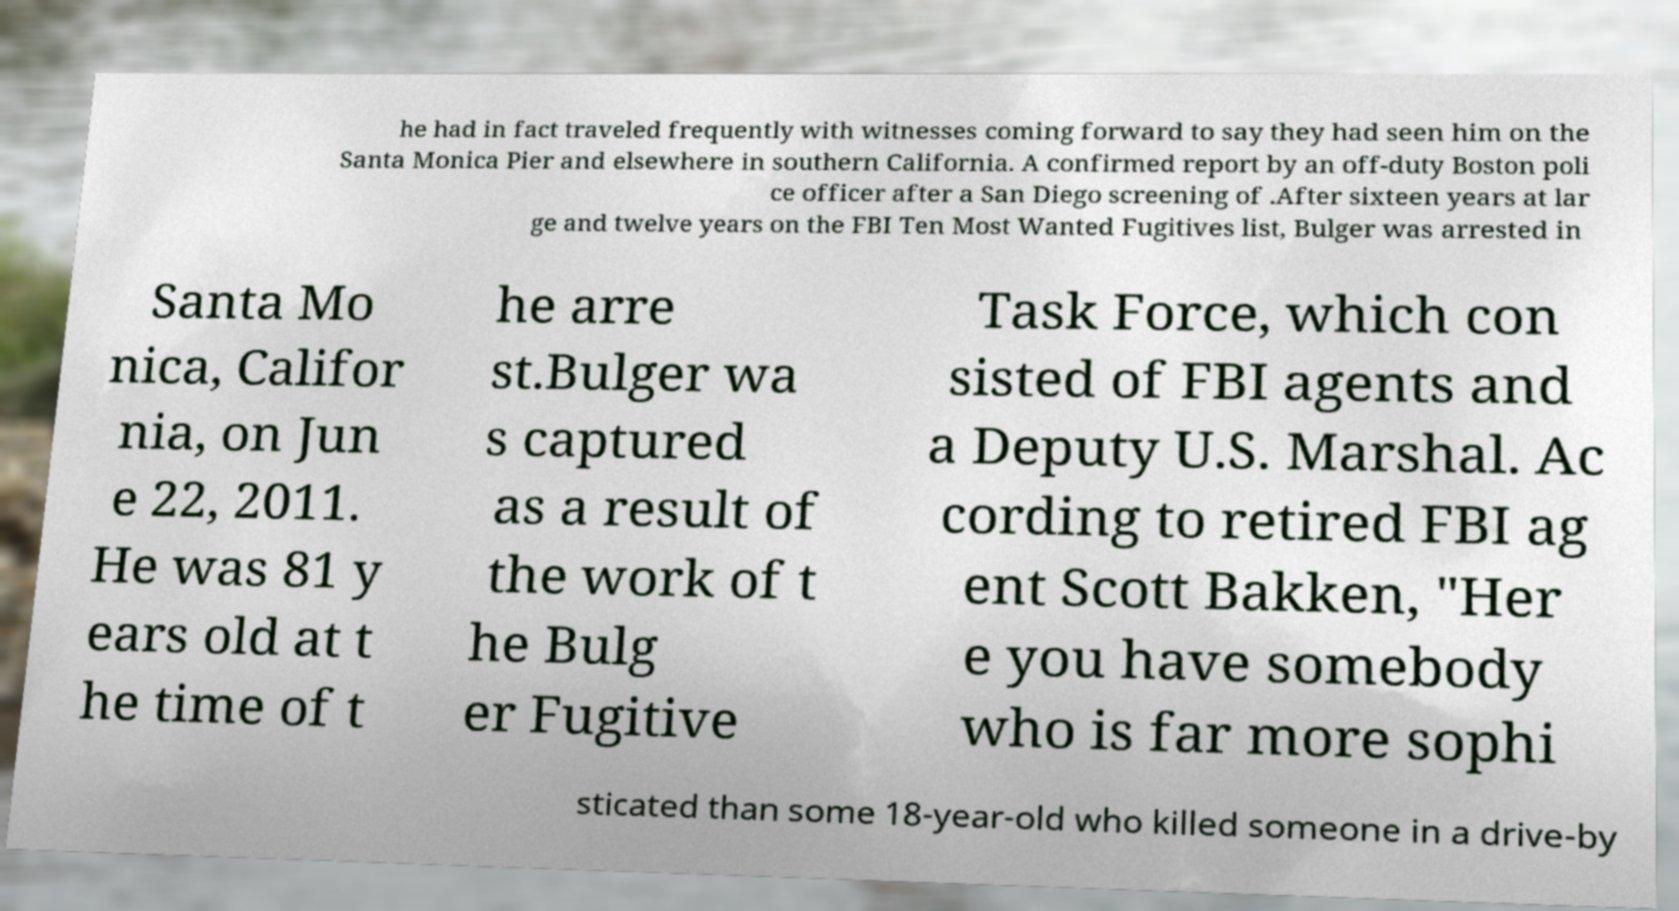Could you assist in decoding the text presented in this image and type it out clearly? he had in fact traveled frequently with witnesses coming forward to say they had seen him on the Santa Monica Pier and elsewhere in southern California. A confirmed report by an off-duty Boston poli ce officer after a San Diego screening of .After sixteen years at lar ge and twelve years on the FBI Ten Most Wanted Fugitives list, Bulger was arrested in Santa Mo nica, Califor nia, on Jun e 22, 2011. He was 81 y ears old at t he time of t he arre st.Bulger wa s captured as a result of the work of t he Bulg er Fugitive Task Force, which con sisted of FBI agents and a Deputy U.S. Marshal. Ac cording to retired FBI ag ent Scott Bakken, "Her e you have somebody who is far more sophi sticated than some 18-year-old who killed someone in a drive-by 